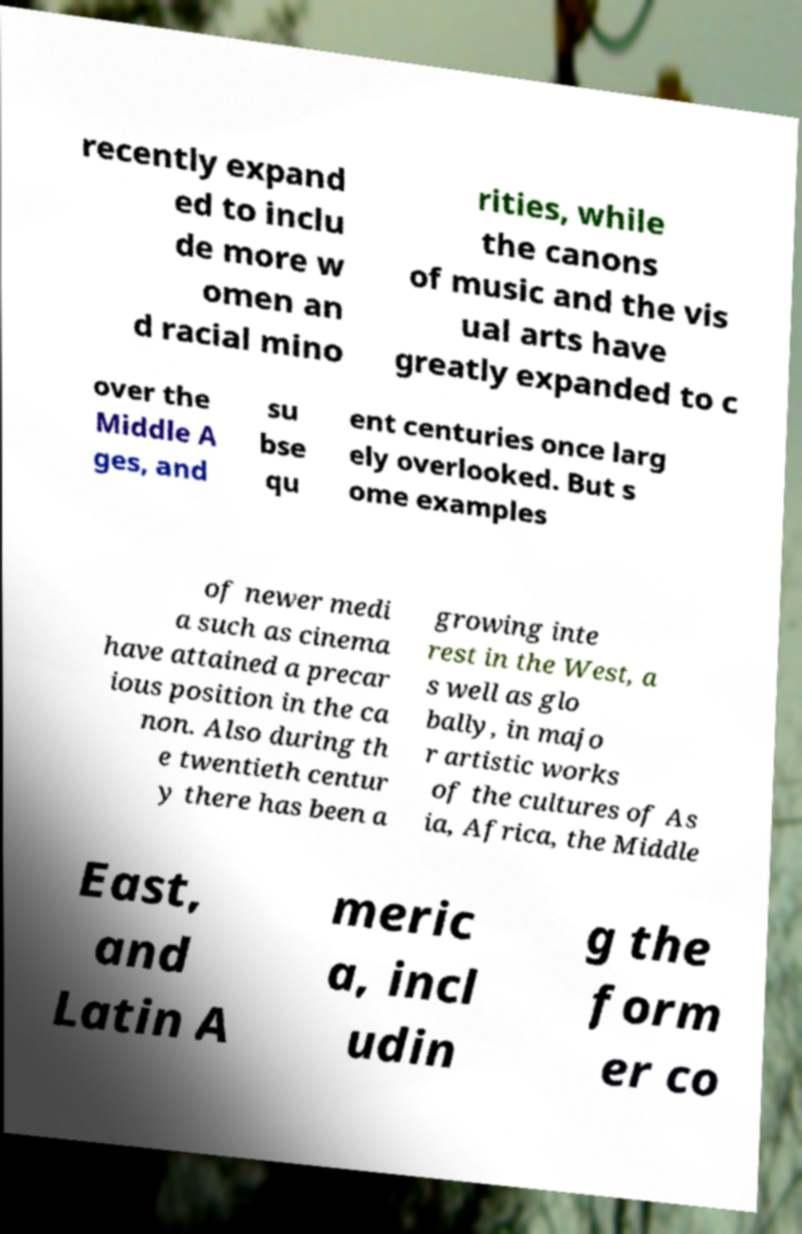Could you assist in decoding the text presented in this image and type it out clearly? recently expand ed to inclu de more w omen an d racial mino rities, while the canons of music and the vis ual arts have greatly expanded to c over the Middle A ges, and su bse qu ent centuries once larg ely overlooked. But s ome examples of newer medi a such as cinema have attained a precar ious position in the ca non. Also during th e twentieth centur y there has been a growing inte rest in the West, a s well as glo bally, in majo r artistic works of the cultures of As ia, Africa, the Middle East, and Latin A meric a, incl udin g the form er co 